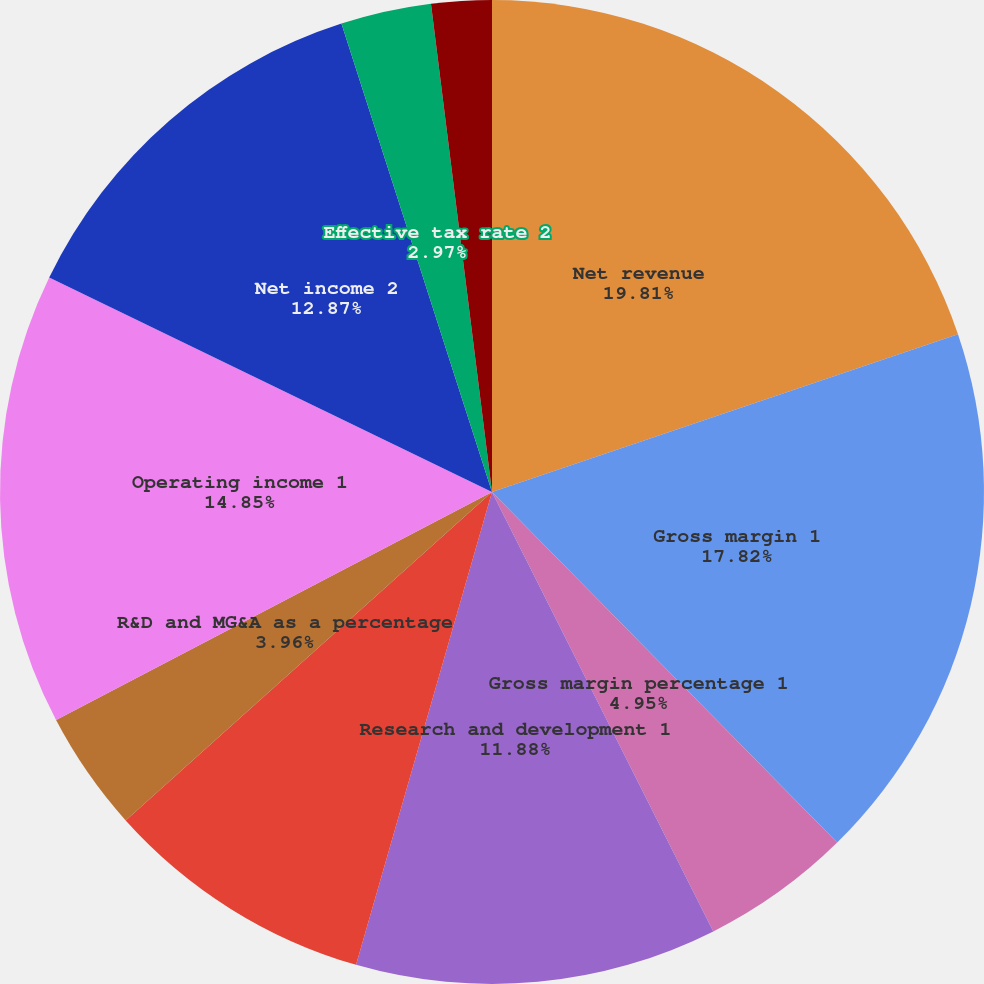Convert chart. <chart><loc_0><loc_0><loc_500><loc_500><pie_chart><fcel>Net revenue<fcel>Gross margin 1<fcel>Gross margin percentage 1<fcel>Research and development 1<fcel>Marketing general and<fcel>R&D and MG&A as a percentage<fcel>Operating income 1<fcel>Net income 2<fcel>Effective tax rate 2<fcel>Basic<nl><fcel>19.8%<fcel>17.82%<fcel>4.95%<fcel>11.88%<fcel>8.91%<fcel>3.96%<fcel>14.85%<fcel>12.87%<fcel>2.97%<fcel>1.98%<nl></chart> 